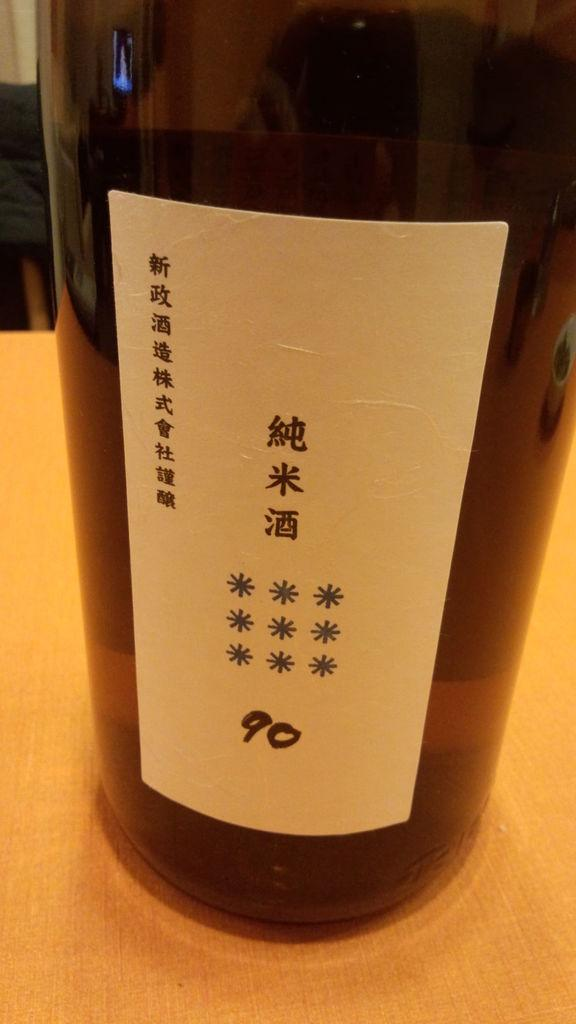What object is present on the table in the image? There is a bottle on the table in the image. What is attached to the bottle? There is a sticker on the bottle. What does the sticker say? The sticker has the text "Nine Zero, Ninety" on it. Can you see any signs of wealth at the seashore in the image? There is no seashore present in the image, and therefore no signs of wealth can be observed. 